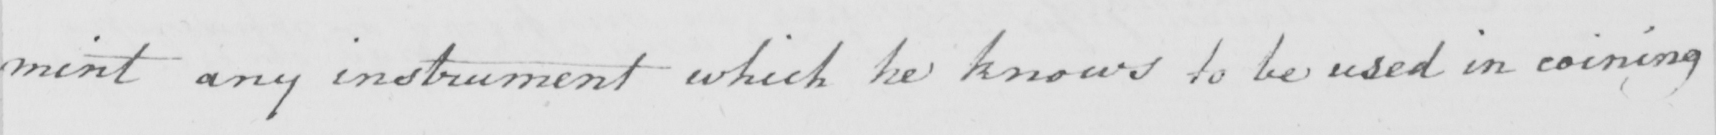What is written in this line of handwriting? mint any instrument which he knows to be used in coining 